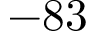<formula> <loc_0><loc_0><loc_500><loc_500>- 8 3</formula> 